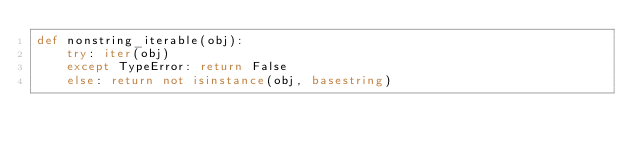Convert code to text. <code><loc_0><loc_0><loc_500><loc_500><_Python_>def nonstring_iterable(obj):
    try: iter(obj)
    except TypeError: return False
    else: return not isinstance(obj, basestring)
</code> 